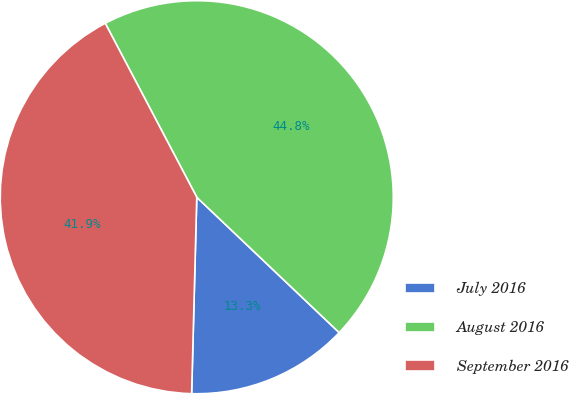Convert chart. <chart><loc_0><loc_0><loc_500><loc_500><pie_chart><fcel>July 2016<fcel>August 2016<fcel>September 2016<nl><fcel>13.32%<fcel>44.81%<fcel>41.88%<nl></chart> 